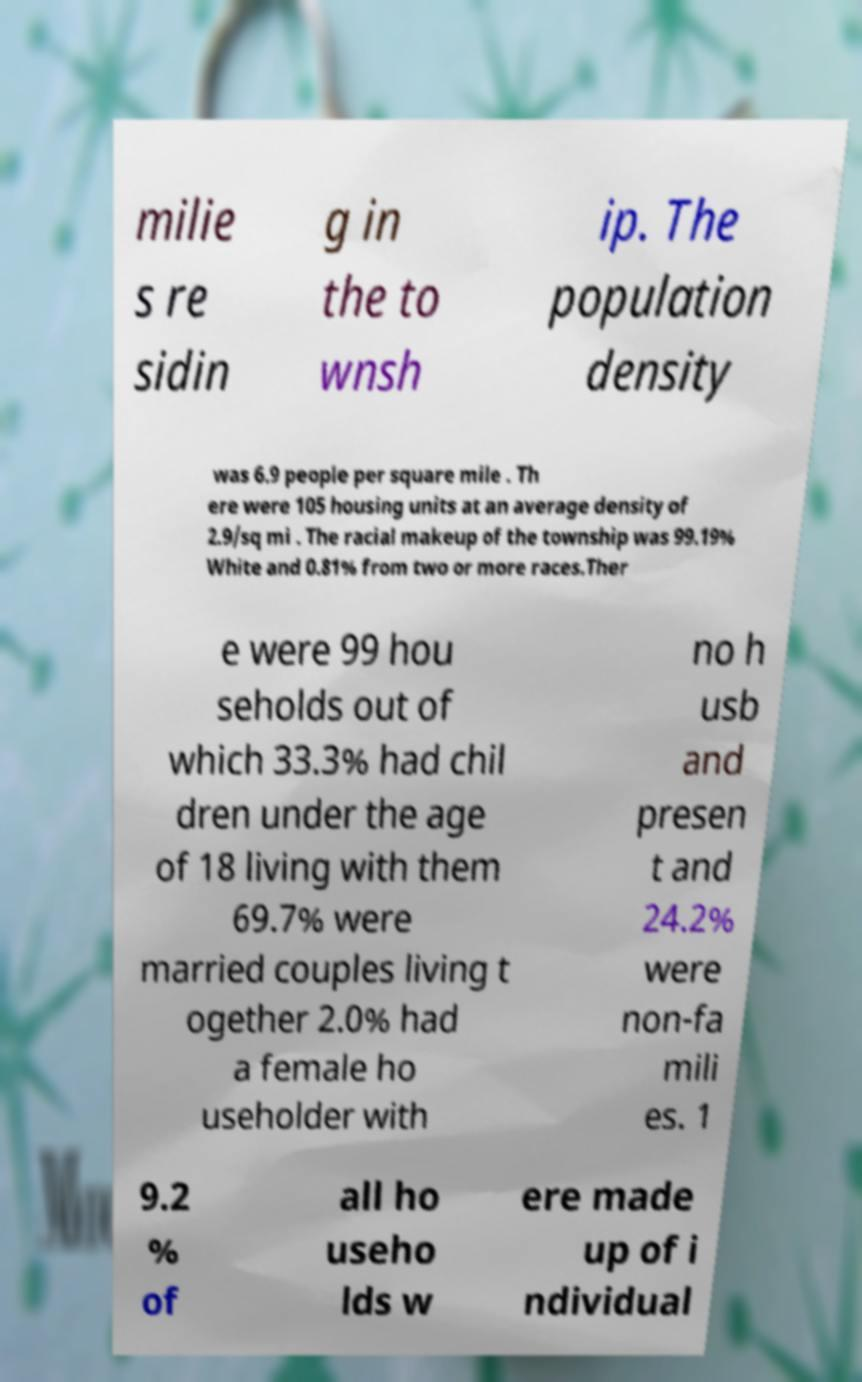Could you assist in decoding the text presented in this image and type it out clearly? milie s re sidin g in the to wnsh ip. The population density was 6.9 people per square mile . Th ere were 105 housing units at an average density of 2.9/sq mi . The racial makeup of the township was 99.19% White and 0.81% from two or more races.Ther e were 99 hou seholds out of which 33.3% had chil dren under the age of 18 living with them 69.7% were married couples living t ogether 2.0% had a female ho useholder with no h usb and presen t and 24.2% were non-fa mili es. 1 9.2 % of all ho useho lds w ere made up of i ndividual 